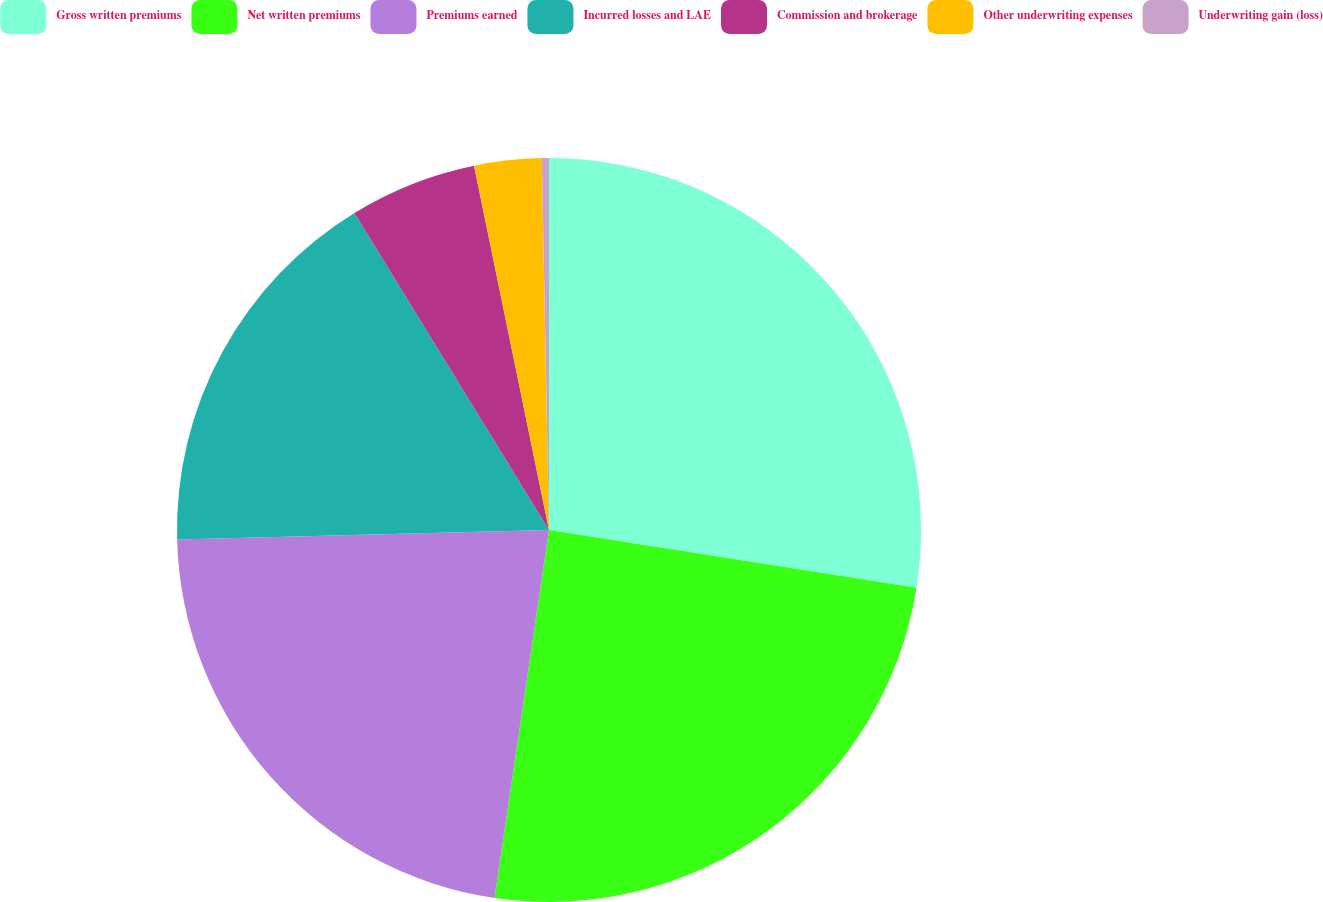Convert chart to OTSL. <chart><loc_0><loc_0><loc_500><loc_500><pie_chart><fcel>Gross written premiums<fcel>Net written premiums<fcel>Premiums earned<fcel>Incurred losses and LAE<fcel>Commission and brokerage<fcel>Other underwriting expenses<fcel>Underwriting gain (loss)<nl><fcel>27.48%<fcel>24.86%<fcel>22.25%<fcel>16.65%<fcel>5.53%<fcel>2.92%<fcel>0.31%<nl></chart> 